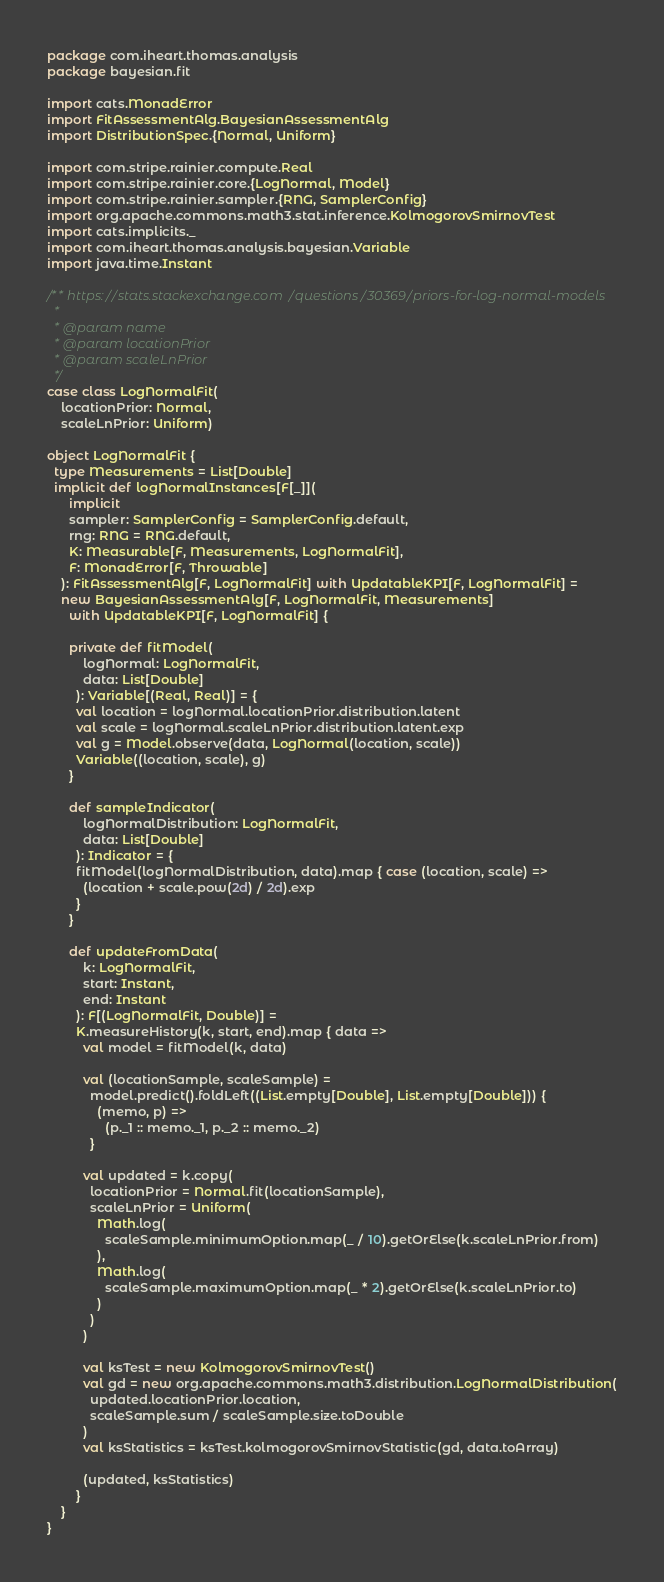Convert code to text. <code><loc_0><loc_0><loc_500><loc_500><_Scala_>package com.iheart.thomas.analysis
package bayesian.fit

import cats.MonadError
import FitAssessmentAlg.BayesianAssessmentAlg
import DistributionSpec.{Normal, Uniform}

import com.stripe.rainier.compute.Real
import com.stripe.rainier.core.{LogNormal, Model}
import com.stripe.rainier.sampler.{RNG, SamplerConfig}
import org.apache.commons.math3.stat.inference.KolmogorovSmirnovTest
import cats.implicits._
import com.iheart.thomas.analysis.bayesian.Variable
import java.time.Instant

/** https://stats.stackexchange.com/questions/30369/priors-for-log-normal-models
  *
  * @param name
  * @param locationPrior
  * @param scaleLnPrior
  */
case class LogNormalFit(
    locationPrior: Normal,
    scaleLnPrior: Uniform)

object LogNormalFit {
  type Measurements = List[Double]
  implicit def logNormalInstances[F[_]](
      implicit
      sampler: SamplerConfig = SamplerConfig.default,
      rng: RNG = RNG.default,
      K: Measurable[F, Measurements, LogNormalFit],
      F: MonadError[F, Throwable]
    ): FitAssessmentAlg[F, LogNormalFit] with UpdatableKPI[F, LogNormalFit] =
    new BayesianAssessmentAlg[F, LogNormalFit, Measurements]
      with UpdatableKPI[F, LogNormalFit] {

      private def fitModel(
          logNormal: LogNormalFit,
          data: List[Double]
        ): Variable[(Real, Real)] = {
        val location = logNormal.locationPrior.distribution.latent
        val scale = logNormal.scaleLnPrior.distribution.latent.exp
        val g = Model.observe(data, LogNormal(location, scale))
        Variable((location, scale), g)
      }

      def sampleIndicator(
          logNormalDistribution: LogNormalFit,
          data: List[Double]
        ): Indicator = {
        fitModel(logNormalDistribution, data).map { case (location, scale) =>
          (location + scale.pow(2d) / 2d).exp
        }
      }

      def updateFromData(
          k: LogNormalFit,
          start: Instant,
          end: Instant
        ): F[(LogNormalFit, Double)] =
        K.measureHistory(k, start, end).map { data =>
          val model = fitModel(k, data)

          val (locationSample, scaleSample) =
            model.predict().foldLeft((List.empty[Double], List.empty[Double])) {
              (memo, p) =>
                (p._1 :: memo._1, p._2 :: memo._2)
            }

          val updated = k.copy(
            locationPrior = Normal.fit(locationSample),
            scaleLnPrior = Uniform(
              Math.log(
                scaleSample.minimumOption.map(_ / 10).getOrElse(k.scaleLnPrior.from)
              ),
              Math.log(
                scaleSample.maximumOption.map(_ * 2).getOrElse(k.scaleLnPrior.to)
              )
            )
          )

          val ksTest = new KolmogorovSmirnovTest()
          val gd = new org.apache.commons.math3.distribution.LogNormalDistribution(
            updated.locationPrior.location,
            scaleSample.sum / scaleSample.size.toDouble
          )
          val ksStatistics = ksTest.kolmogorovSmirnovStatistic(gd, data.toArray)

          (updated, ksStatistics)
        }
    }
}
</code> 